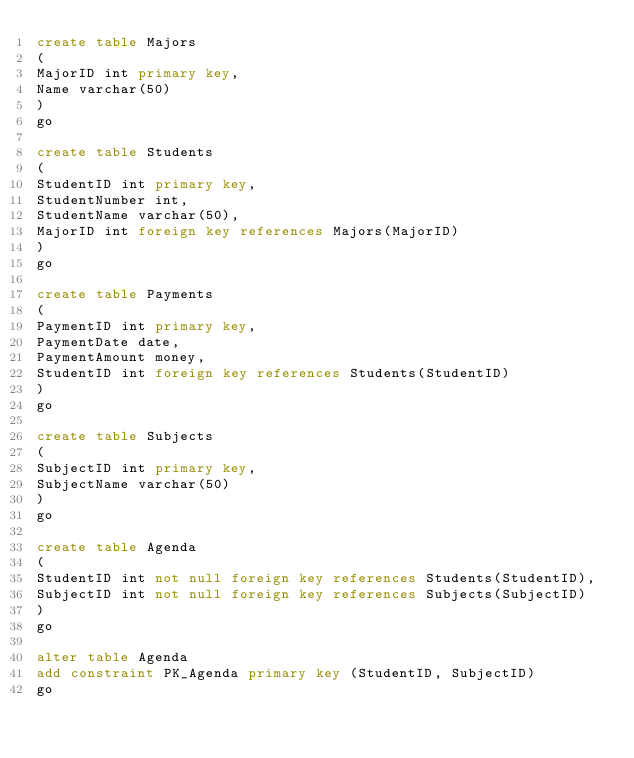<code> <loc_0><loc_0><loc_500><loc_500><_SQL_>create table Majors
(
MajorID int primary key,
Name varchar(50)
)
go

create table Students
(
StudentID int primary key,
StudentNumber int,
StudentName varchar(50),
MajorID int foreign key references Majors(MajorID)
)
go

create table Payments
(
PaymentID int primary key,
PaymentDate date,
PaymentAmount money,
StudentID int foreign key references Students(StudentID)
)
go

create table Subjects
(
SubjectID int primary key,
SubjectName varchar(50)
)
go

create table Agenda
(
StudentID int not null foreign key references Students(StudentID),
SubjectID int not null foreign key references Subjects(SubjectID)
)
go

alter table Agenda
add constraint PK_Agenda primary key (StudentID, SubjectID)
go</code> 